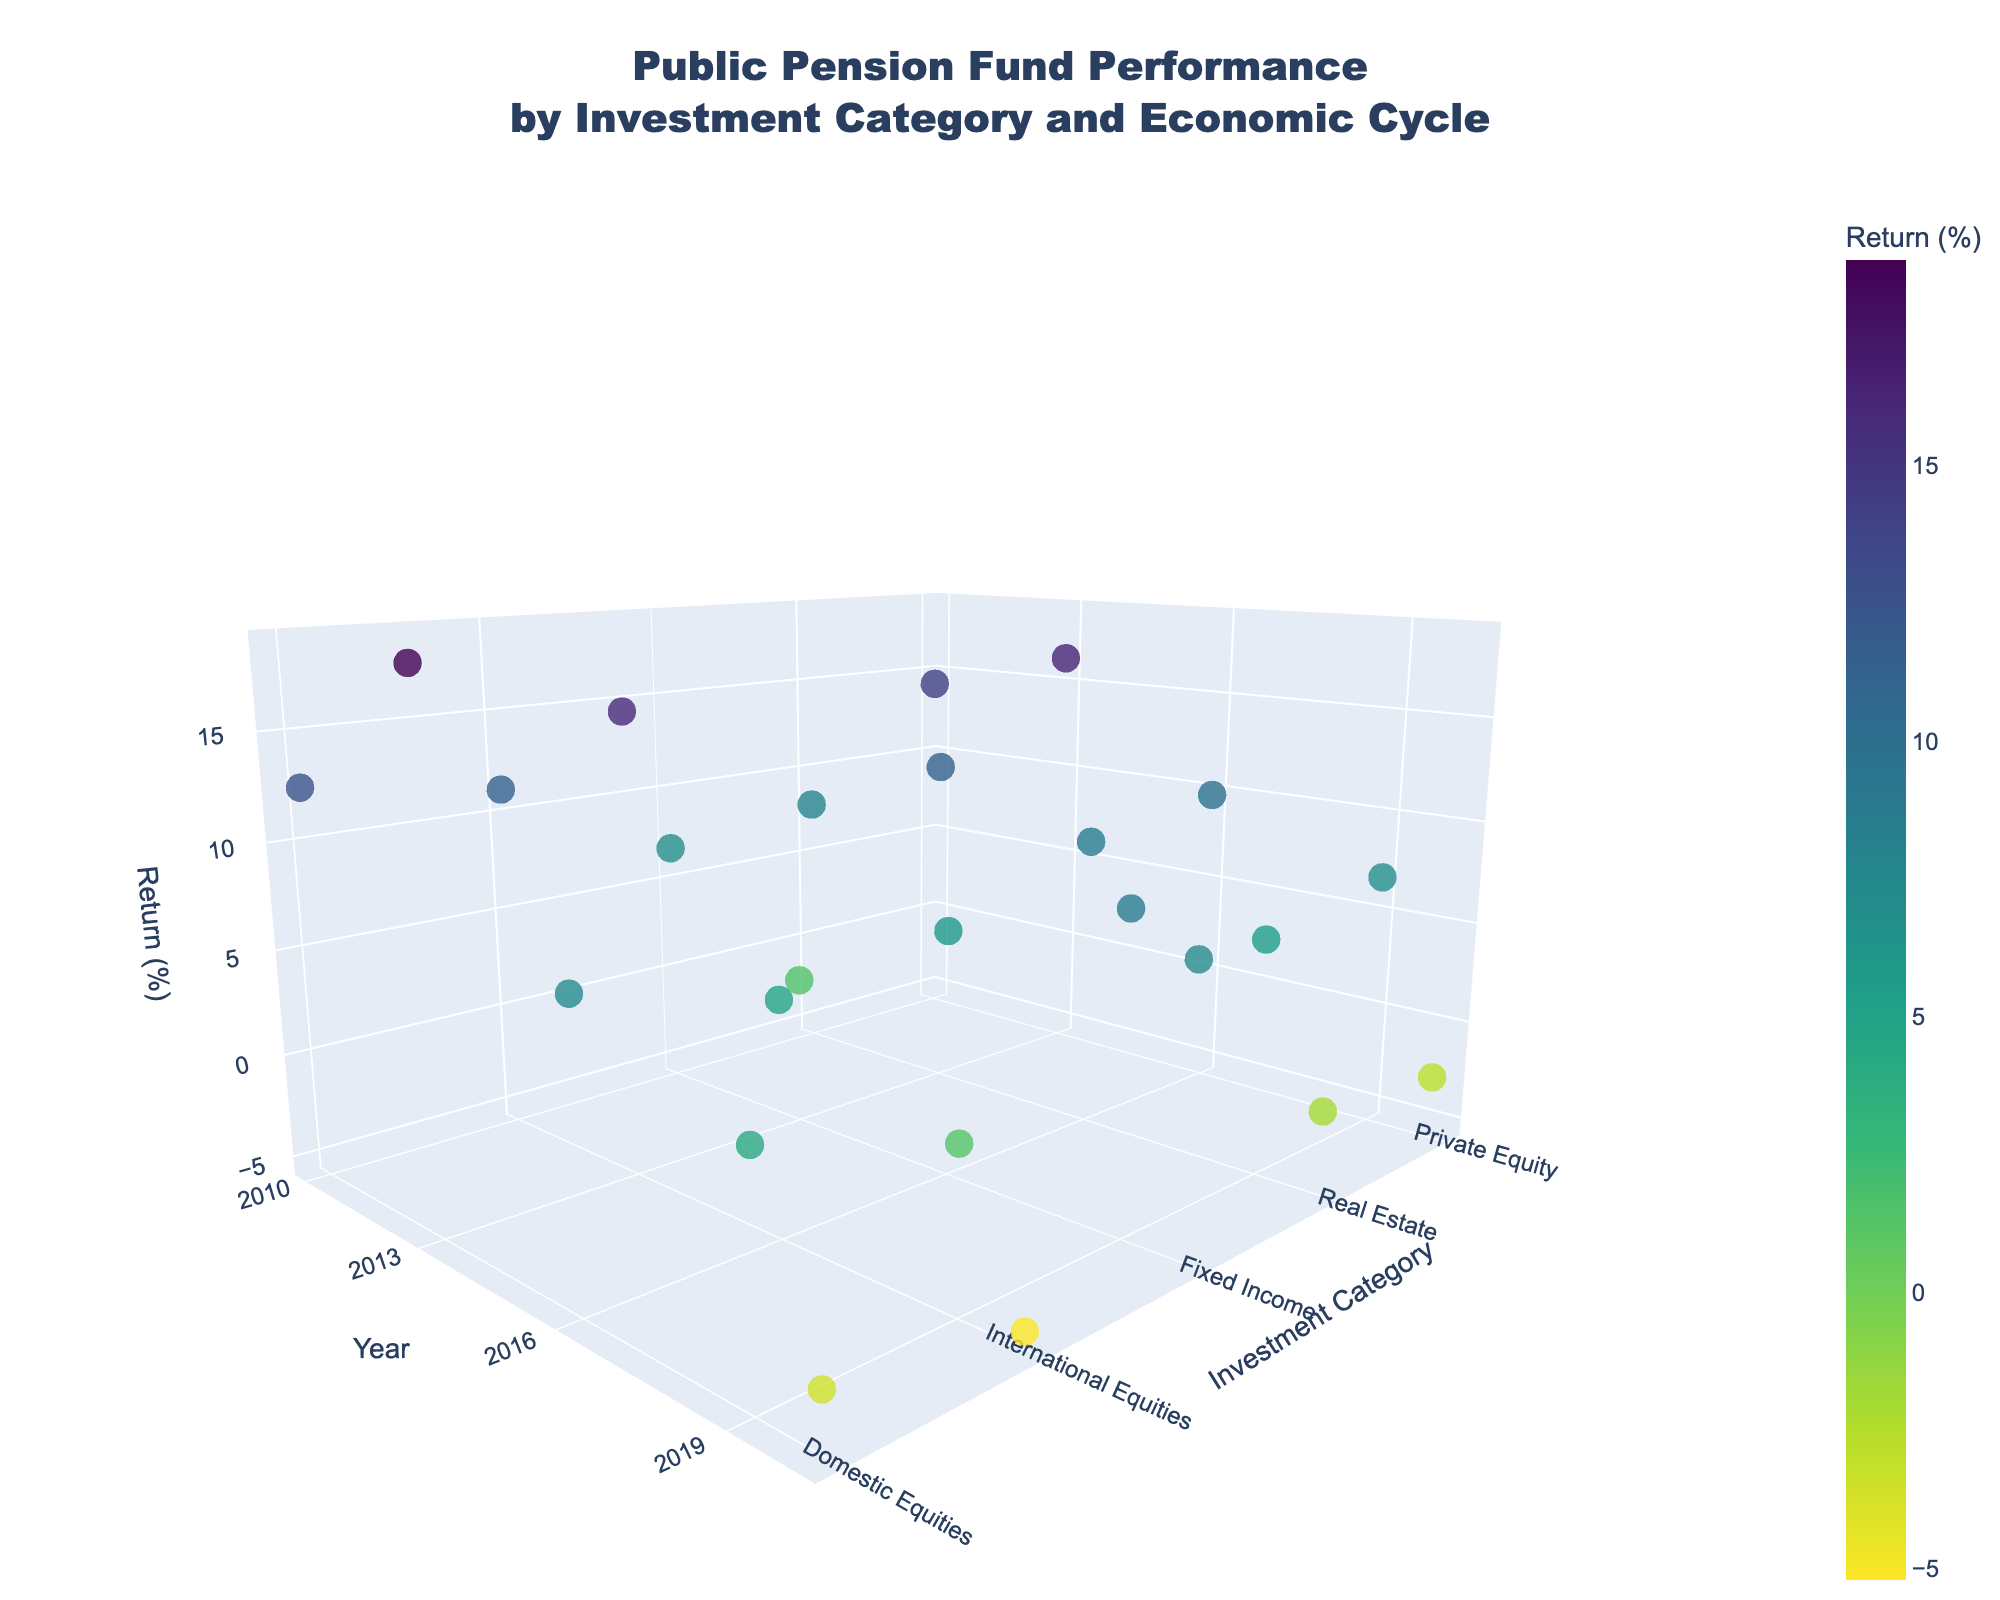What is the title of the 3D plot? The title is located at the top of the plot and reads "Public Pension Fund Performance by Investment Category and Economic Cycle."
Answer: Public Pension Fund Performance by Investment Category and Economic Cycle How many investment categories are presented in the plot? By looking at the 'y-axis', you can visually count the number of distinct investment categories listed: Domestic Equities, International Equities, Fixed Income, Real Estate, and Private Equity.
Answer: Five Which year had the worst performance for Domestic Equities, and what was the return percentage? Look at the 'z-axis' (Return) values for Domestic Equities (y-axis) and find the lowest value. This occurs in 2020, with a return percentage of -3.5%.
Answer: 2020, -3.5% Between Domestic Equities and Private Equity, which category had a higher return in 2010 during the Early Expansion cycle? Compare the 'z-axis' values for both categories in 2010. Domestic Equities had a return of 12.5%, while Private Equity had a return of 14.1%.
Answer: Private Equity What is the average return for Fixed Income during all economic cycles? Average the 'z-axis' values for Fixed Income across different years: (6.8 + 1.5 + 5.9 + 8.7 + 7.2) / 5 = 6.02%.
Answer: 6.02% In which economic cycle did International Equities achieve its highest return, and what was the return? Examine the 'z-axis' values for International Equities and find the highest one. The highest return is 15.9% during the Mid Expansion cycle in 2013.
Answer: Mid Expansion, 15.9% Which investment category had the most stable performance across different economic cycles, based on visual inspection of return percentages? By looking at the 'z-axis' values, Fixed Income appears to be the most stable as its returns don't fluctuate as widely compared to other categories.
Answer: Fixed Income Compare the performance of Real Estate and International Equities in the year 2016. Which category had better returns? Look at the 'z-axis' values for both categories in 2016: Real Estate had a return of 8.6%, while International Equities had a return of 4.8%.
Answer: Real Estate How do the returns of Private Equity change from the Early Expansion cycle to the Recession cycle? Compare the 'z-axis' values for Private Equity in 2010 and 2020. The return drops from 14.1% to -2.8%.
Answer: Decreases by 16.9 percentage points What is the overall trend in returns for Domestic Equities from 2010 to 2020? Examine the 'z-axis' values for Domestic Equities over the years: 12.5% (2010), 18.7% (2013), 7.2% (2016), 4.1% (2019), -3.5% (2020). The returns generally decrease over time.
Answer: Decreasing trend 